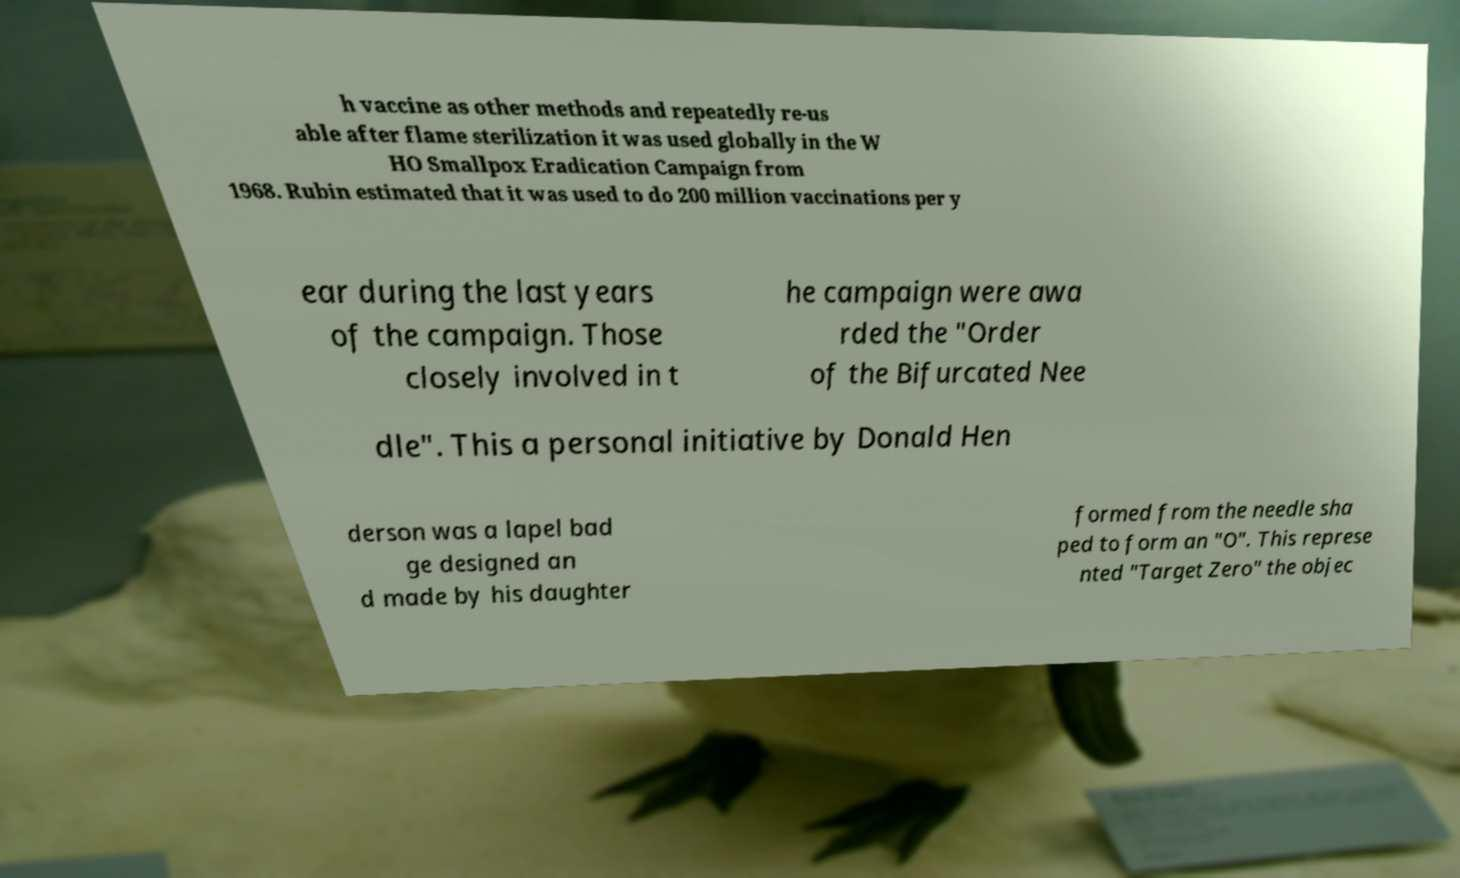For documentation purposes, I need the text within this image transcribed. Could you provide that? h vaccine as other methods and repeatedly re-us able after flame sterilization it was used globally in the W HO Smallpox Eradication Campaign from 1968. Rubin estimated that it was used to do 200 million vaccinations per y ear during the last years of the campaign. Those closely involved in t he campaign were awa rded the "Order of the Bifurcated Nee dle". This a personal initiative by Donald Hen derson was a lapel bad ge designed an d made by his daughter formed from the needle sha ped to form an "O". This represe nted "Target Zero" the objec 